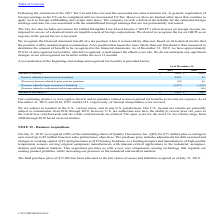From Cts Corporation's financial document, Which years does the table provide information for the reconciliation of the beginning and ending unrecognized tax benefits? The document shows two values: 2019 and 2018. From the document: "2019 2018 2019 2018..." Also, What was the Increase related to current year tax positions in 2018? According to the financial document, 55 (in thousands). The relevant text states: "rease related to current year tax positions 2,834 55..." Also, What was the amount of interest and penalties accrued that were related to unrecognized tax benefits as income tax expense in 2019? According to the financial document, 707 (in thousands). The relevant text states: "tax expense. As of December 31, 2019, and 2018, $707 and $2,515, respectively, of interest and penalties were accrued...." Also, can you calculate: What was the change in the Increase related to current year tax positions between 2018 and 2019? Based on the calculation: 2,834-55, the result is 2779 (in thousands). This is based on the information: "Increase related to current year tax positions 2,834 55 rease related to current year tax positions 2,834 55..." The key data points involved are: 2,834, 55. Also, can you calculate: What was the change in the balance at January 1 between 2018 and 2019? Based on the calculation: 3,649-4,670, the result is -1021 (in thousands). This is based on the information: "Balance at January 1 $ 3,649 $ 4,670 Balance at January 1 $ 3,649 $ 4,670..." The key data points involved are: 3,649, 4,670. Also, can you calculate: What was the percentage change in Balance at December 31 between 2018 and 2019? To answer this question, I need to perform calculations using the financial data. The calculation is: (5,016-3,649)/3,649, which equals 37.46 (percentage). This is based on the information: ". As of December 31, 2019, we have approximately $5,016 of unrecognized tax benefits, which if recognized, would impact the effective tax rate. We do not a Balance at January 1 $ 3,649 $ 4,670..." The key data points involved are: 3,649, 5,016. 